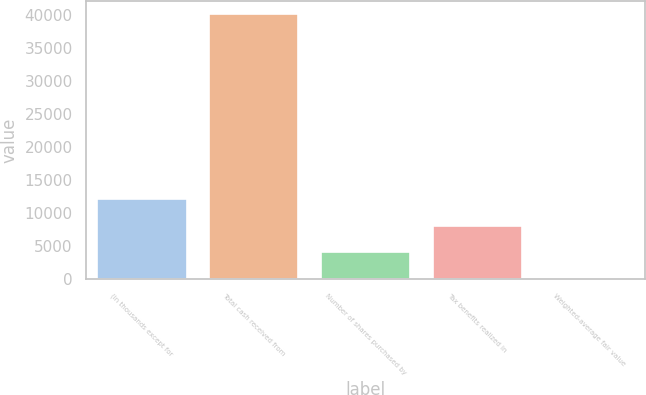Convert chart to OTSL. <chart><loc_0><loc_0><loc_500><loc_500><bar_chart><fcel>(in thousands except for<fcel>Total cash received from<fcel>Number of shares purchased by<fcel>Tax benefits realized in<fcel>Weighted-average fair value<nl><fcel>12077.2<fcel>40175<fcel>4049.32<fcel>8063.28<fcel>35.35<nl></chart> 